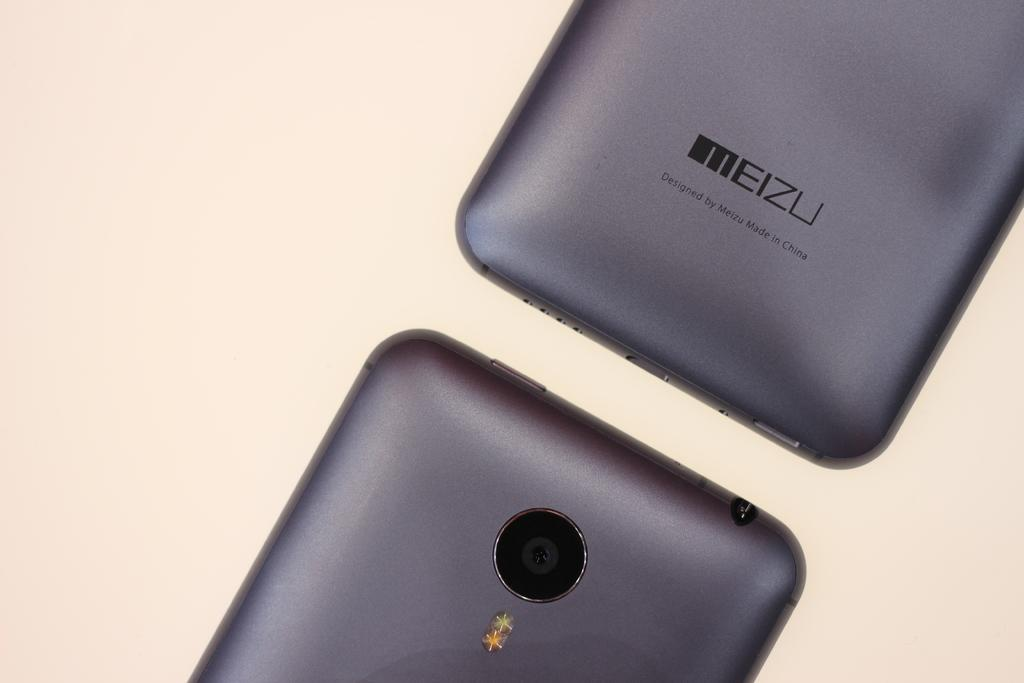Provide a one-sentence caption for the provided image. The rear bottom of a meizu smart phone says Designed by Meizu Made in China and it above the top of another phone. 